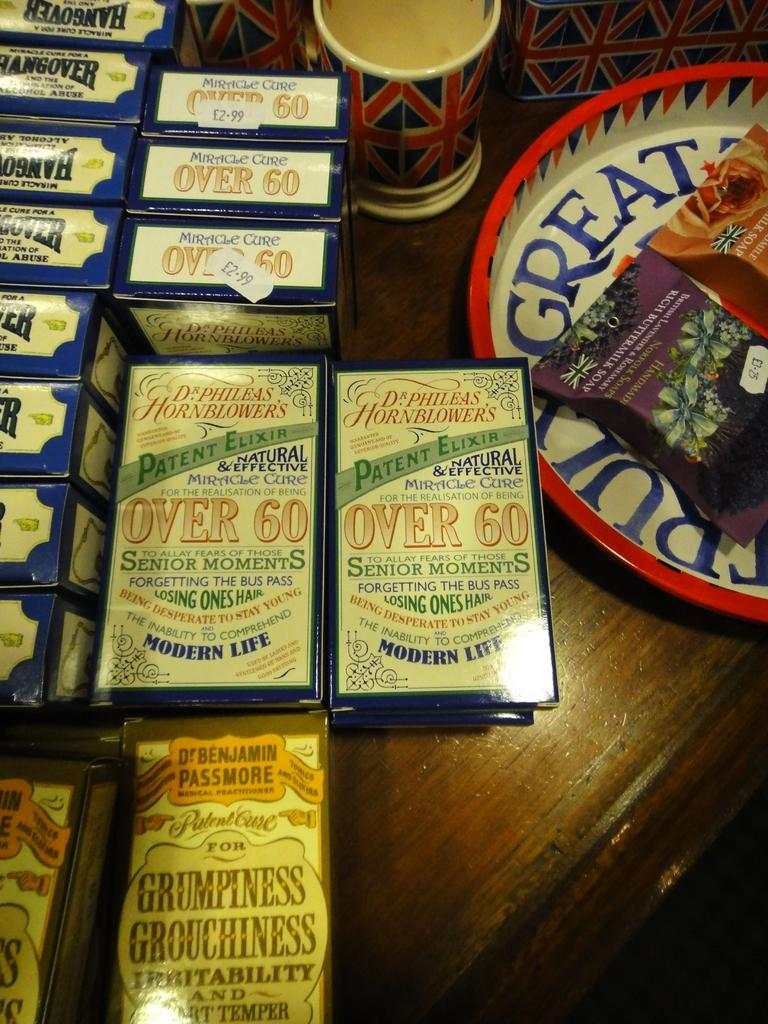Provide a one-sentence caption for the provided image. Playing cards are being displayed for senior citizen game night. 